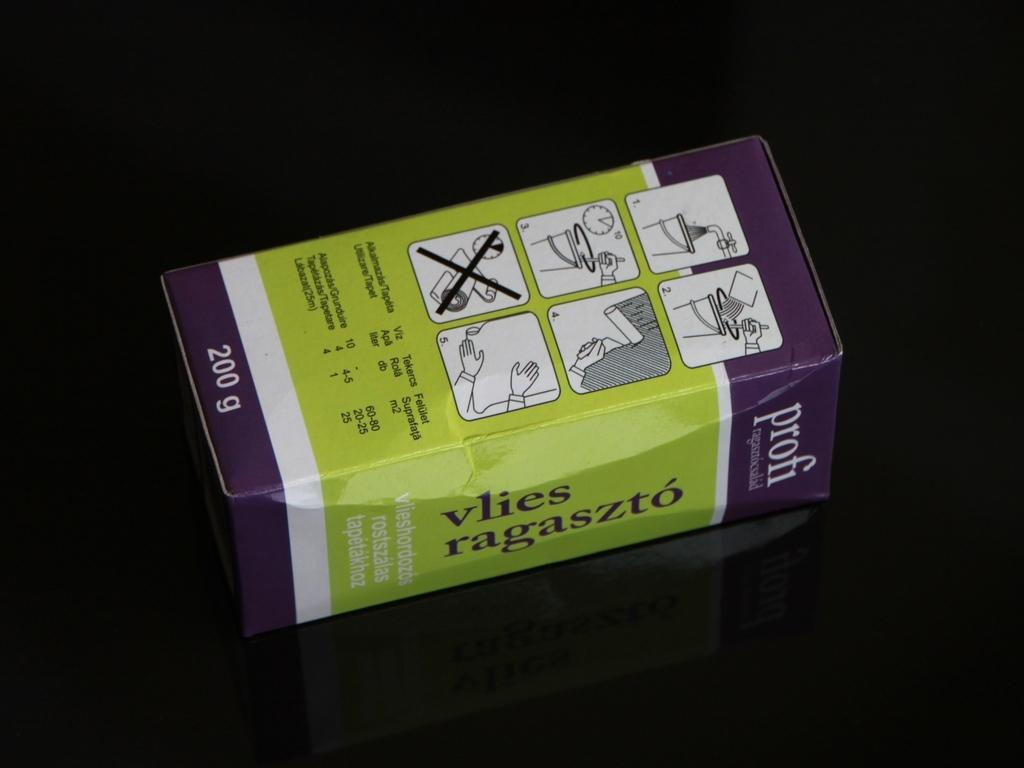<image>
Write a terse but informative summary of the picture. a purple and green box for Profi Vlies Ragaszto 